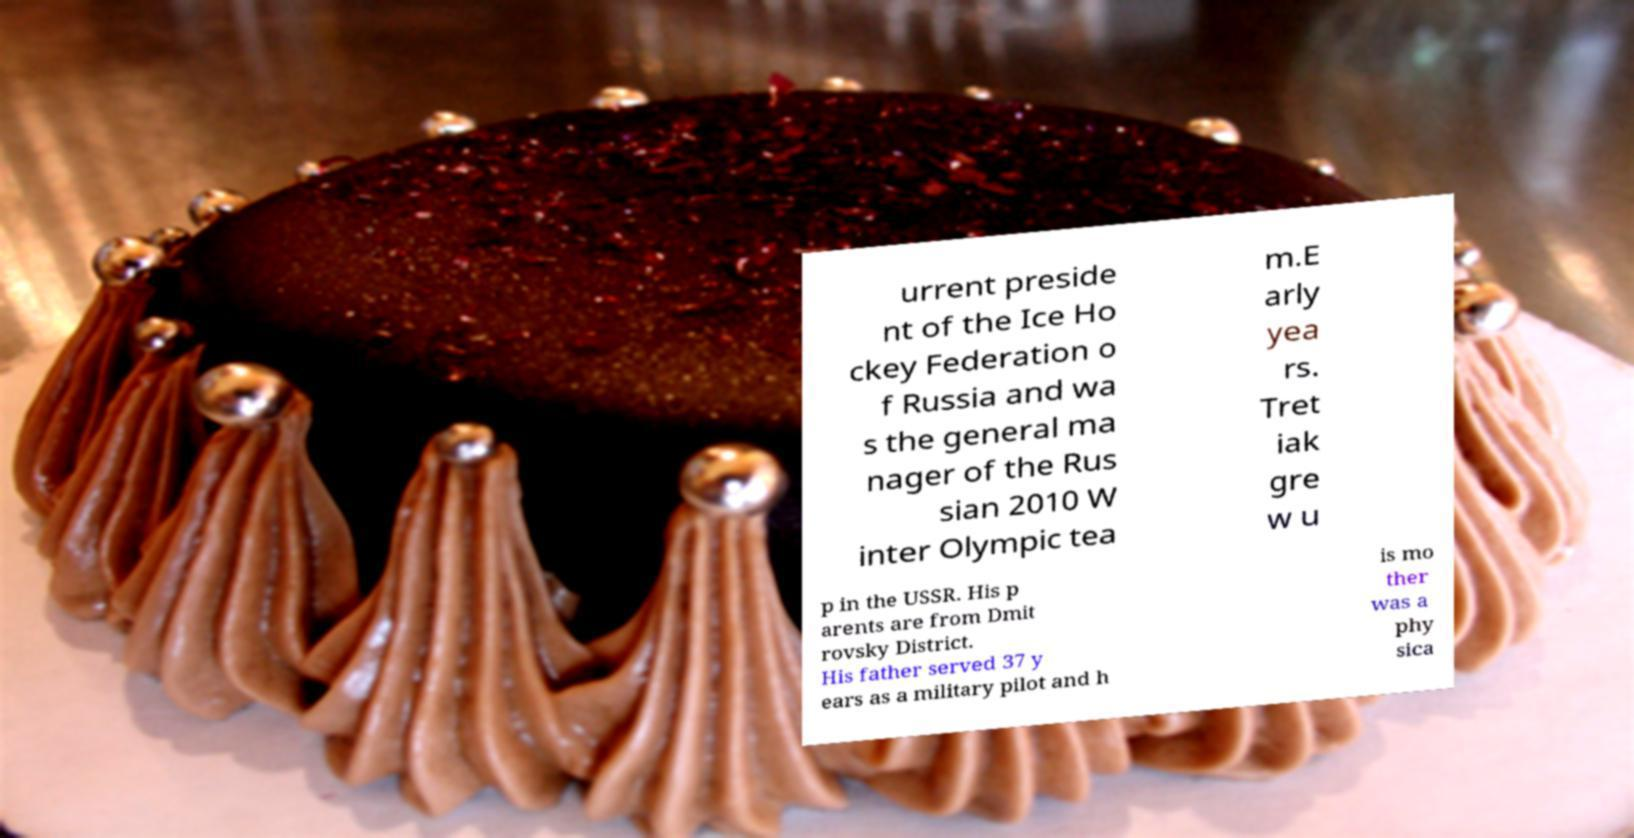Could you assist in decoding the text presented in this image and type it out clearly? urrent preside nt of the Ice Ho ckey Federation o f Russia and wa s the general ma nager of the Rus sian 2010 W inter Olympic tea m.E arly yea rs. Tret iak gre w u p in the USSR. His p arents are from Dmit rovsky District. His father served 37 y ears as a military pilot and h is mo ther was a phy sica 